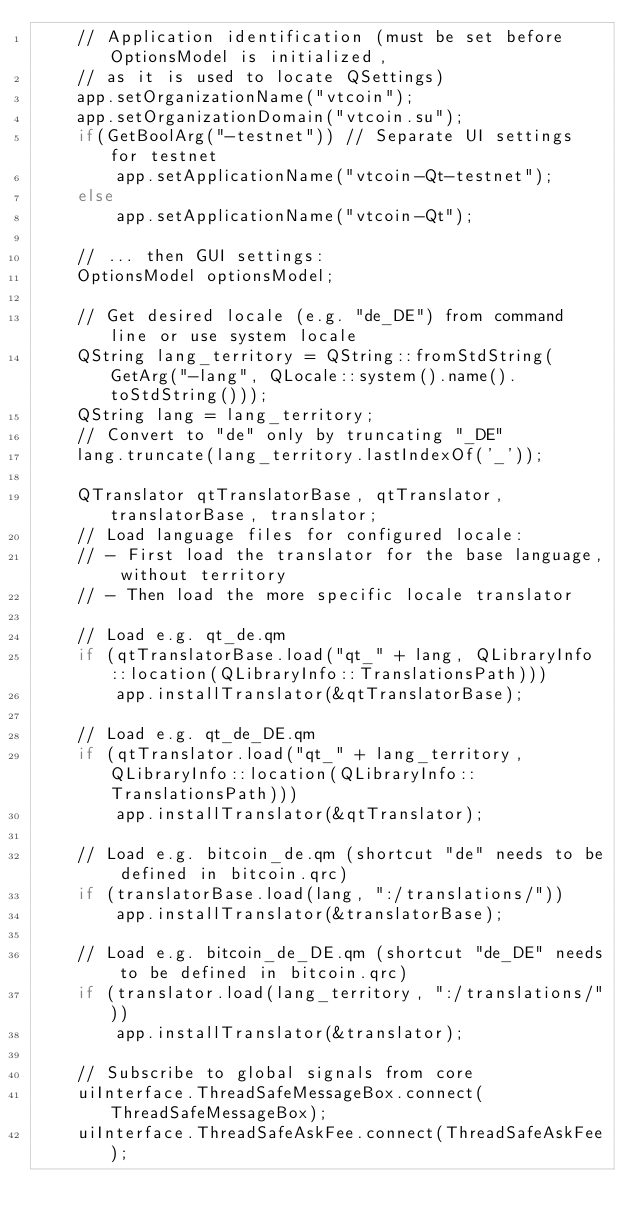Convert code to text. <code><loc_0><loc_0><loc_500><loc_500><_C++_>    // Application identification (must be set before OptionsModel is initialized,
    // as it is used to locate QSettings)
    app.setOrganizationName("vtcoin");
    app.setOrganizationDomain("vtcoin.su");
    if(GetBoolArg("-testnet")) // Separate UI settings for testnet
        app.setApplicationName("vtcoin-Qt-testnet");
    else
        app.setApplicationName("vtcoin-Qt");

    // ... then GUI settings:
    OptionsModel optionsModel;

    // Get desired locale (e.g. "de_DE") from command line or use system locale
    QString lang_territory = QString::fromStdString(GetArg("-lang", QLocale::system().name().toStdString()));
    QString lang = lang_territory;
    // Convert to "de" only by truncating "_DE"
    lang.truncate(lang_territory.lastIndexOf('_'));

    QTranslator qtTranslatorBase, qtTranslator, translatorBase, translator;
    // Load language files for configured locale:
    // - First load the translator for the base language, without territory
    // - Then load the more specific locale translator

    // Load e.g. qt_de.qm
    if (qtTranslatorBase.load("qt_" + lang, QLibraryInfo::location(QLibraryInfo::TranslationsPath)))
        app.installTranslator(&qtTranslatorBase);

    // Load e.g. qt_de_DE.qm
    if (qtTranslator.load("qt_" + lang_territory, QLibraryInfo::location(QLibraryInfo::TranslationsPath)))
        app.installTranslator(&qtTranslator);

    // Load e.g. bitcoin_de.qm (shortcut "de" needs to be defined in bitcoin.qrc)
    if (translatorBase.load(lang, ":/translations/"))
        app.installTranslator(&translatorBase);

    // Load e.g. bitcoin_de_DE.qm (shortcut "de_DE" needs to be defined in bitcoin.qrc)
    if (translator.load(lang_territory, ":/translations/"))
        app.installTranslator(&translator);

    // Subscribe to global signals from core
    uiInterface.ThreadSafeMessageBox.connect(ThreadSafeMessageBox);
    uiInterface.ThreadSafeAskFee.connect(ThreadSafeAskFee);</code> 